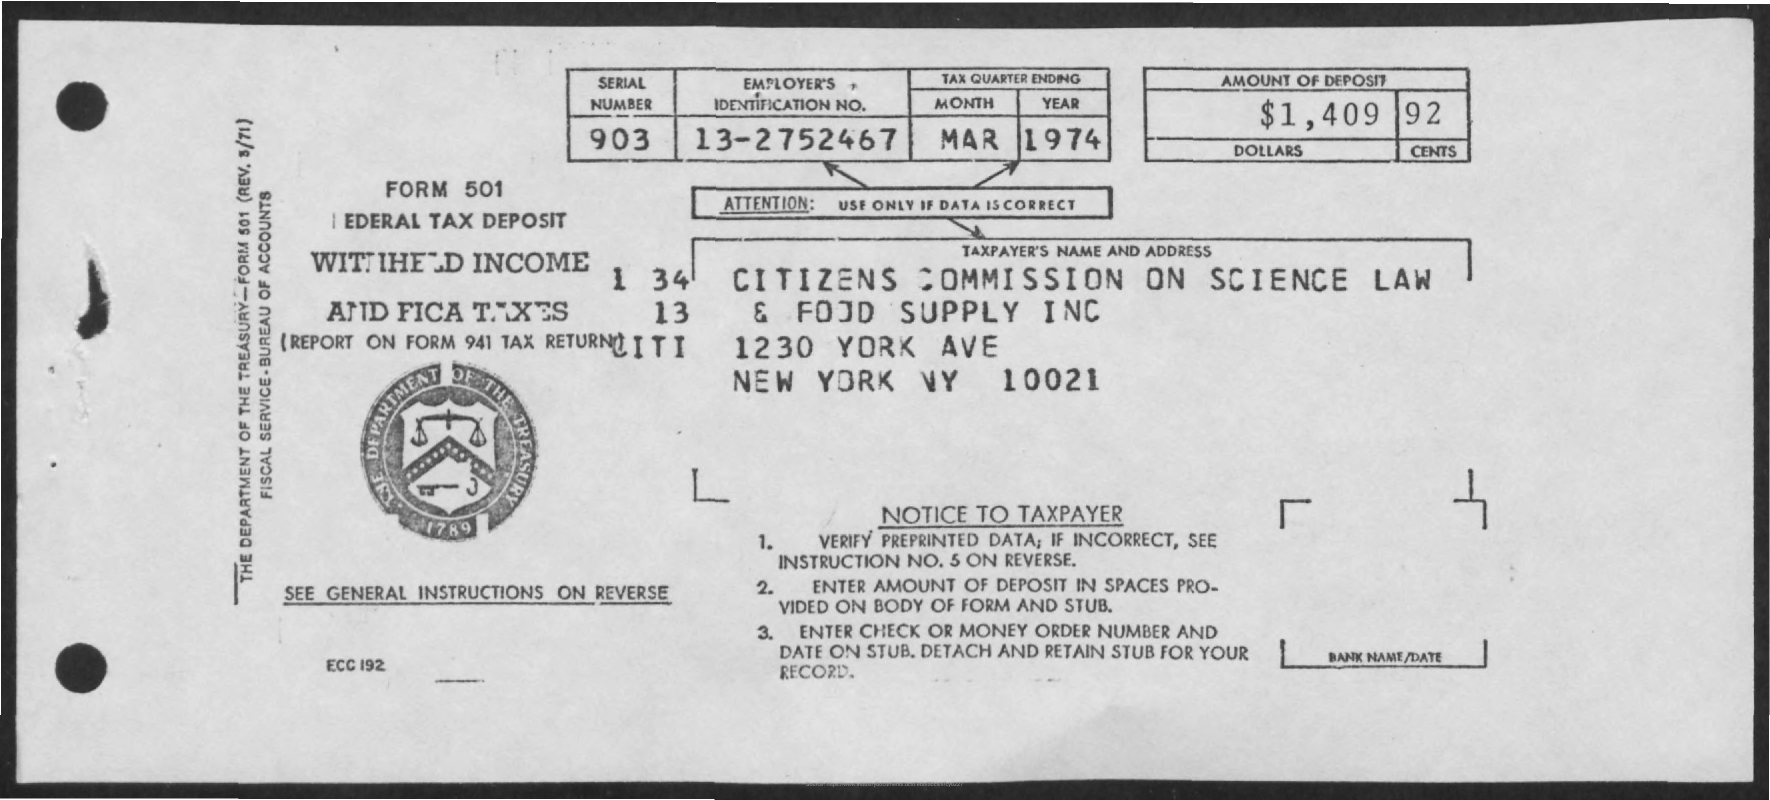Mention a couple of crucial points in this snapshot. The deposit amount is $1,409.92. The serial number is 903. The attention field contains information that is only to be used if the data is correct. 